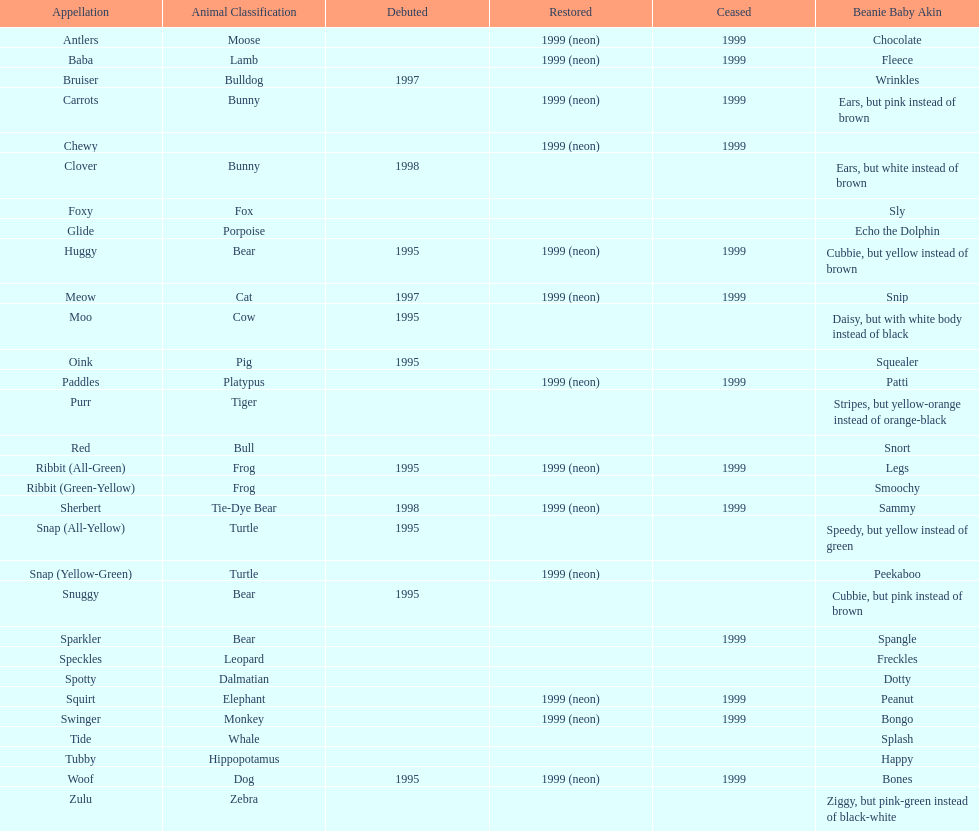Which animal type has the most pillow pals? Bear. 